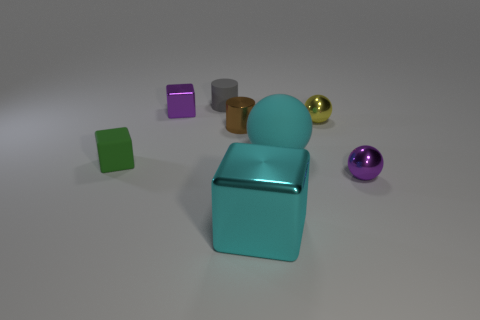Add 1 shiny cylinders. How many objects exist? 9 Subtract all cylinders. How many objects are left? 6 Add 1 tiny green rubber things. How many tiny green rubber things are left? 2 Add 5 large cyan metal cubes. How many large cyan metal cubes exist? 6 Subtract 0 red spheres. How many objects are left? 8 Subtract all big gray matte blocks. Subtract all cyan rubber things. How many objects are left? 7 